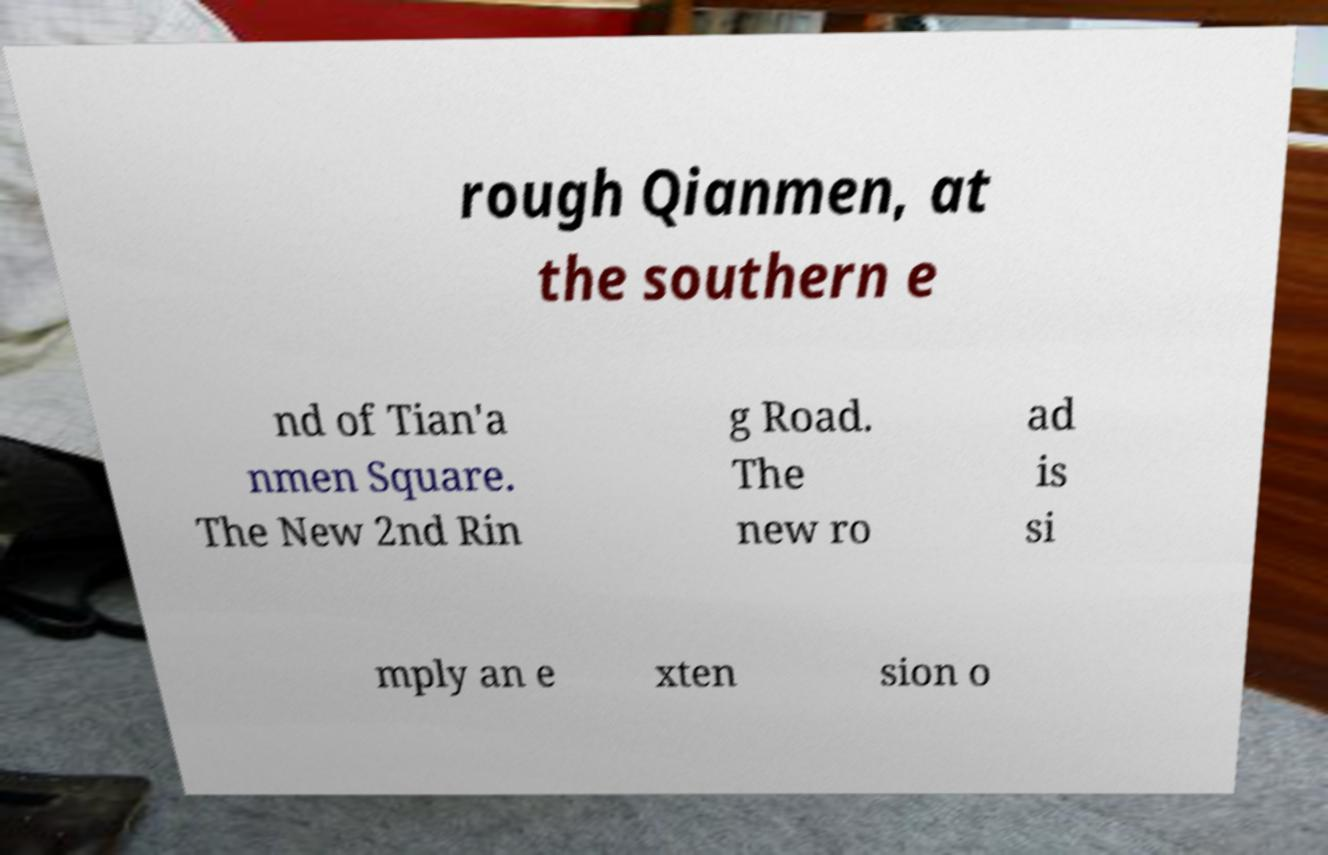Please identify and transcribe the text found in this image. rough Qianmen, at the southern e nd of Tian'a nmen Square. The New 2nd Rin g Road. The new ro ad is si mply an e xten sion o 